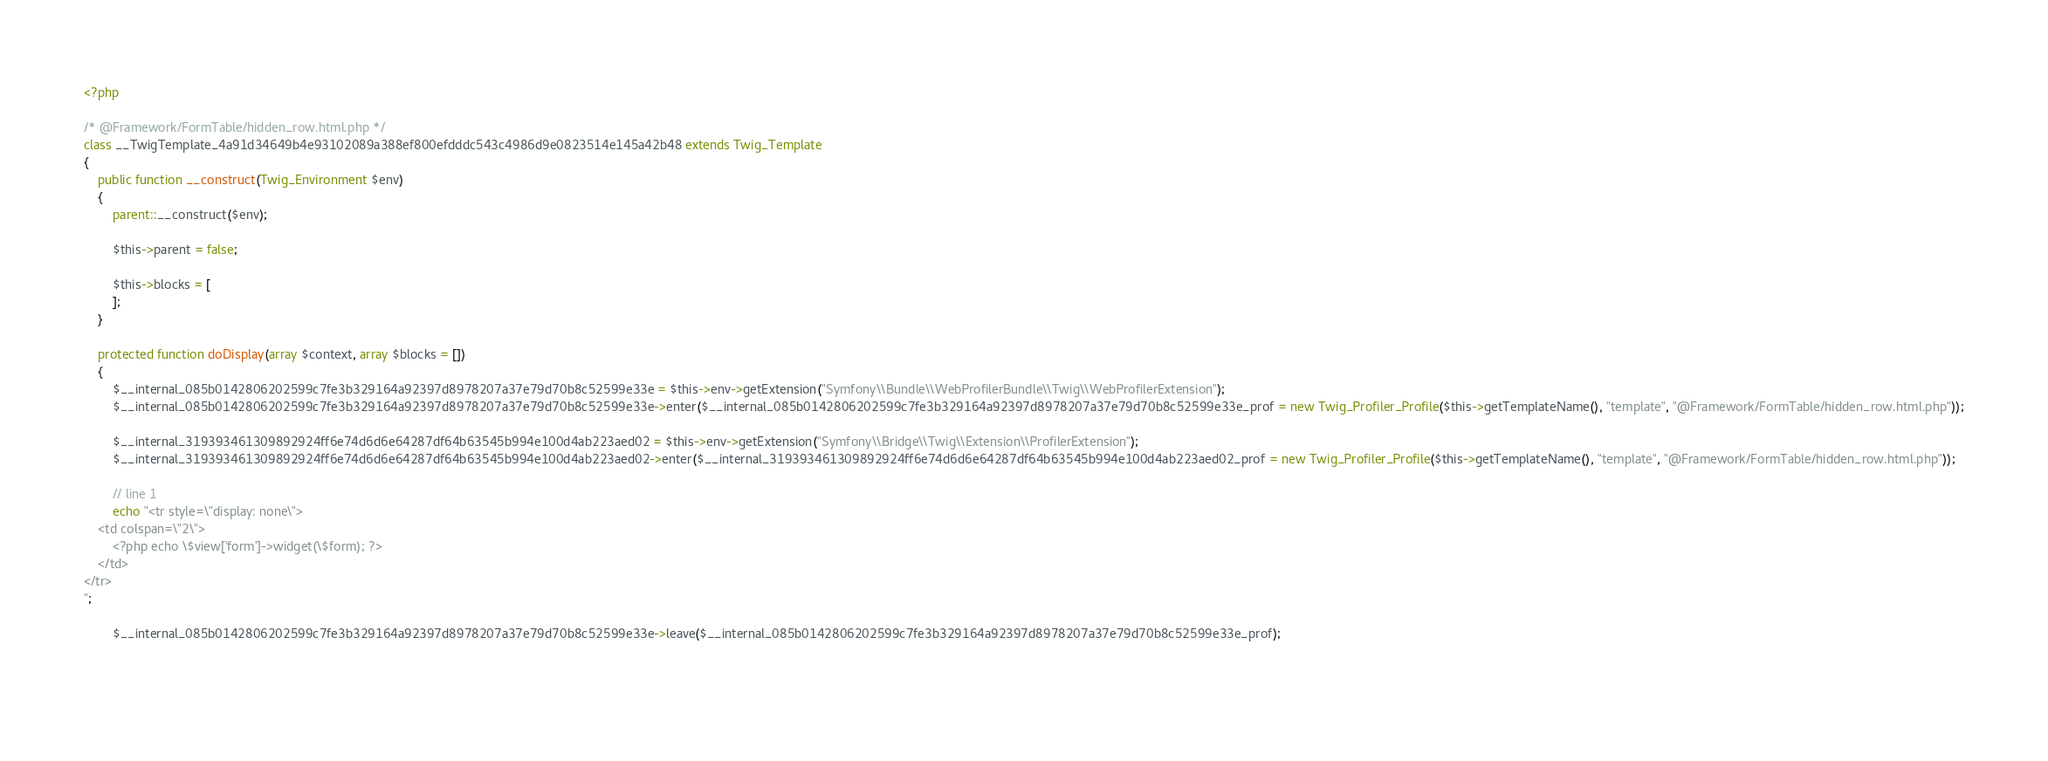Convert code to text. <code><loc_0><loc_0><loc_500><loc_500><_PHP_><?php

/* @Framework/FormTable/hidden_row.html.php */
class __TwigTemplate_4a91d34649b4e93102089a388ef800efdddc543c4986d9e0823514e145a42b48 extends Twig_Template
{
    public function __construct(Twig_Environment $env)
    {
        parent::__construct($env);

        $this->parent = false;

        $this->blocks = [
        ];
    }

    protected function doDisplay(array $context, array $blocks = [])
    {
        $__internal_085b0142806202599c7fe3b329164a92397d8978207a37e79d70b8c52599e33e = $this->env->getExtension("Symfony\\Bundle\\WebProfilerBundle\\Twig\\WebProfilerExtension");
        $__internal_085b0142806202599c7fe3b329164a92397d8978207a37e79d70b8c52599e33e->enter($__internal_085b0142806202599c7fe3b329164a92397d8978207a37e79d70b8c52599e33e_prof = new Twig_Profiler_Profile($this->getTemplateName(), "template", "@Framework/FormTable/hidden_row.html.php"));

        $__internal_319393461309892924ff6e74d6d6e64287df64b63545b994e100d4ab223aed02 = $this->env->getExtension("Symfony\\Bridge\\Twig\\Extension\\ProfilerExtension");
        $__internal_319393461309892924ff6e74d6d6e64287df64b63545b994e100d4ab223aed02->enter($__internal_319393461309892924ff6e74d6d6e64287df64b63545b994e100d4ab223aed02_prof = new Twig_Profiler_Profile($this->getTemplateName(), "template", "@Framework/FormTable/hidden_row.html.php"));

        // line 1
        echo "<tr style=\"display: none\">
    <td colspan=\"2\">
        <?php echo \$view['form']->widget(\$form); ?>
    </td>
</tr>
";
        
        $__internal_085b0142806202599c7fe3b329164a92397d8978207a37e79d70b8c52599e33e->leave($__internal_085b0142806202599c7fe3b329164a92397d8978207a37e79d70b8c52599e33e_prof);

        </code> 